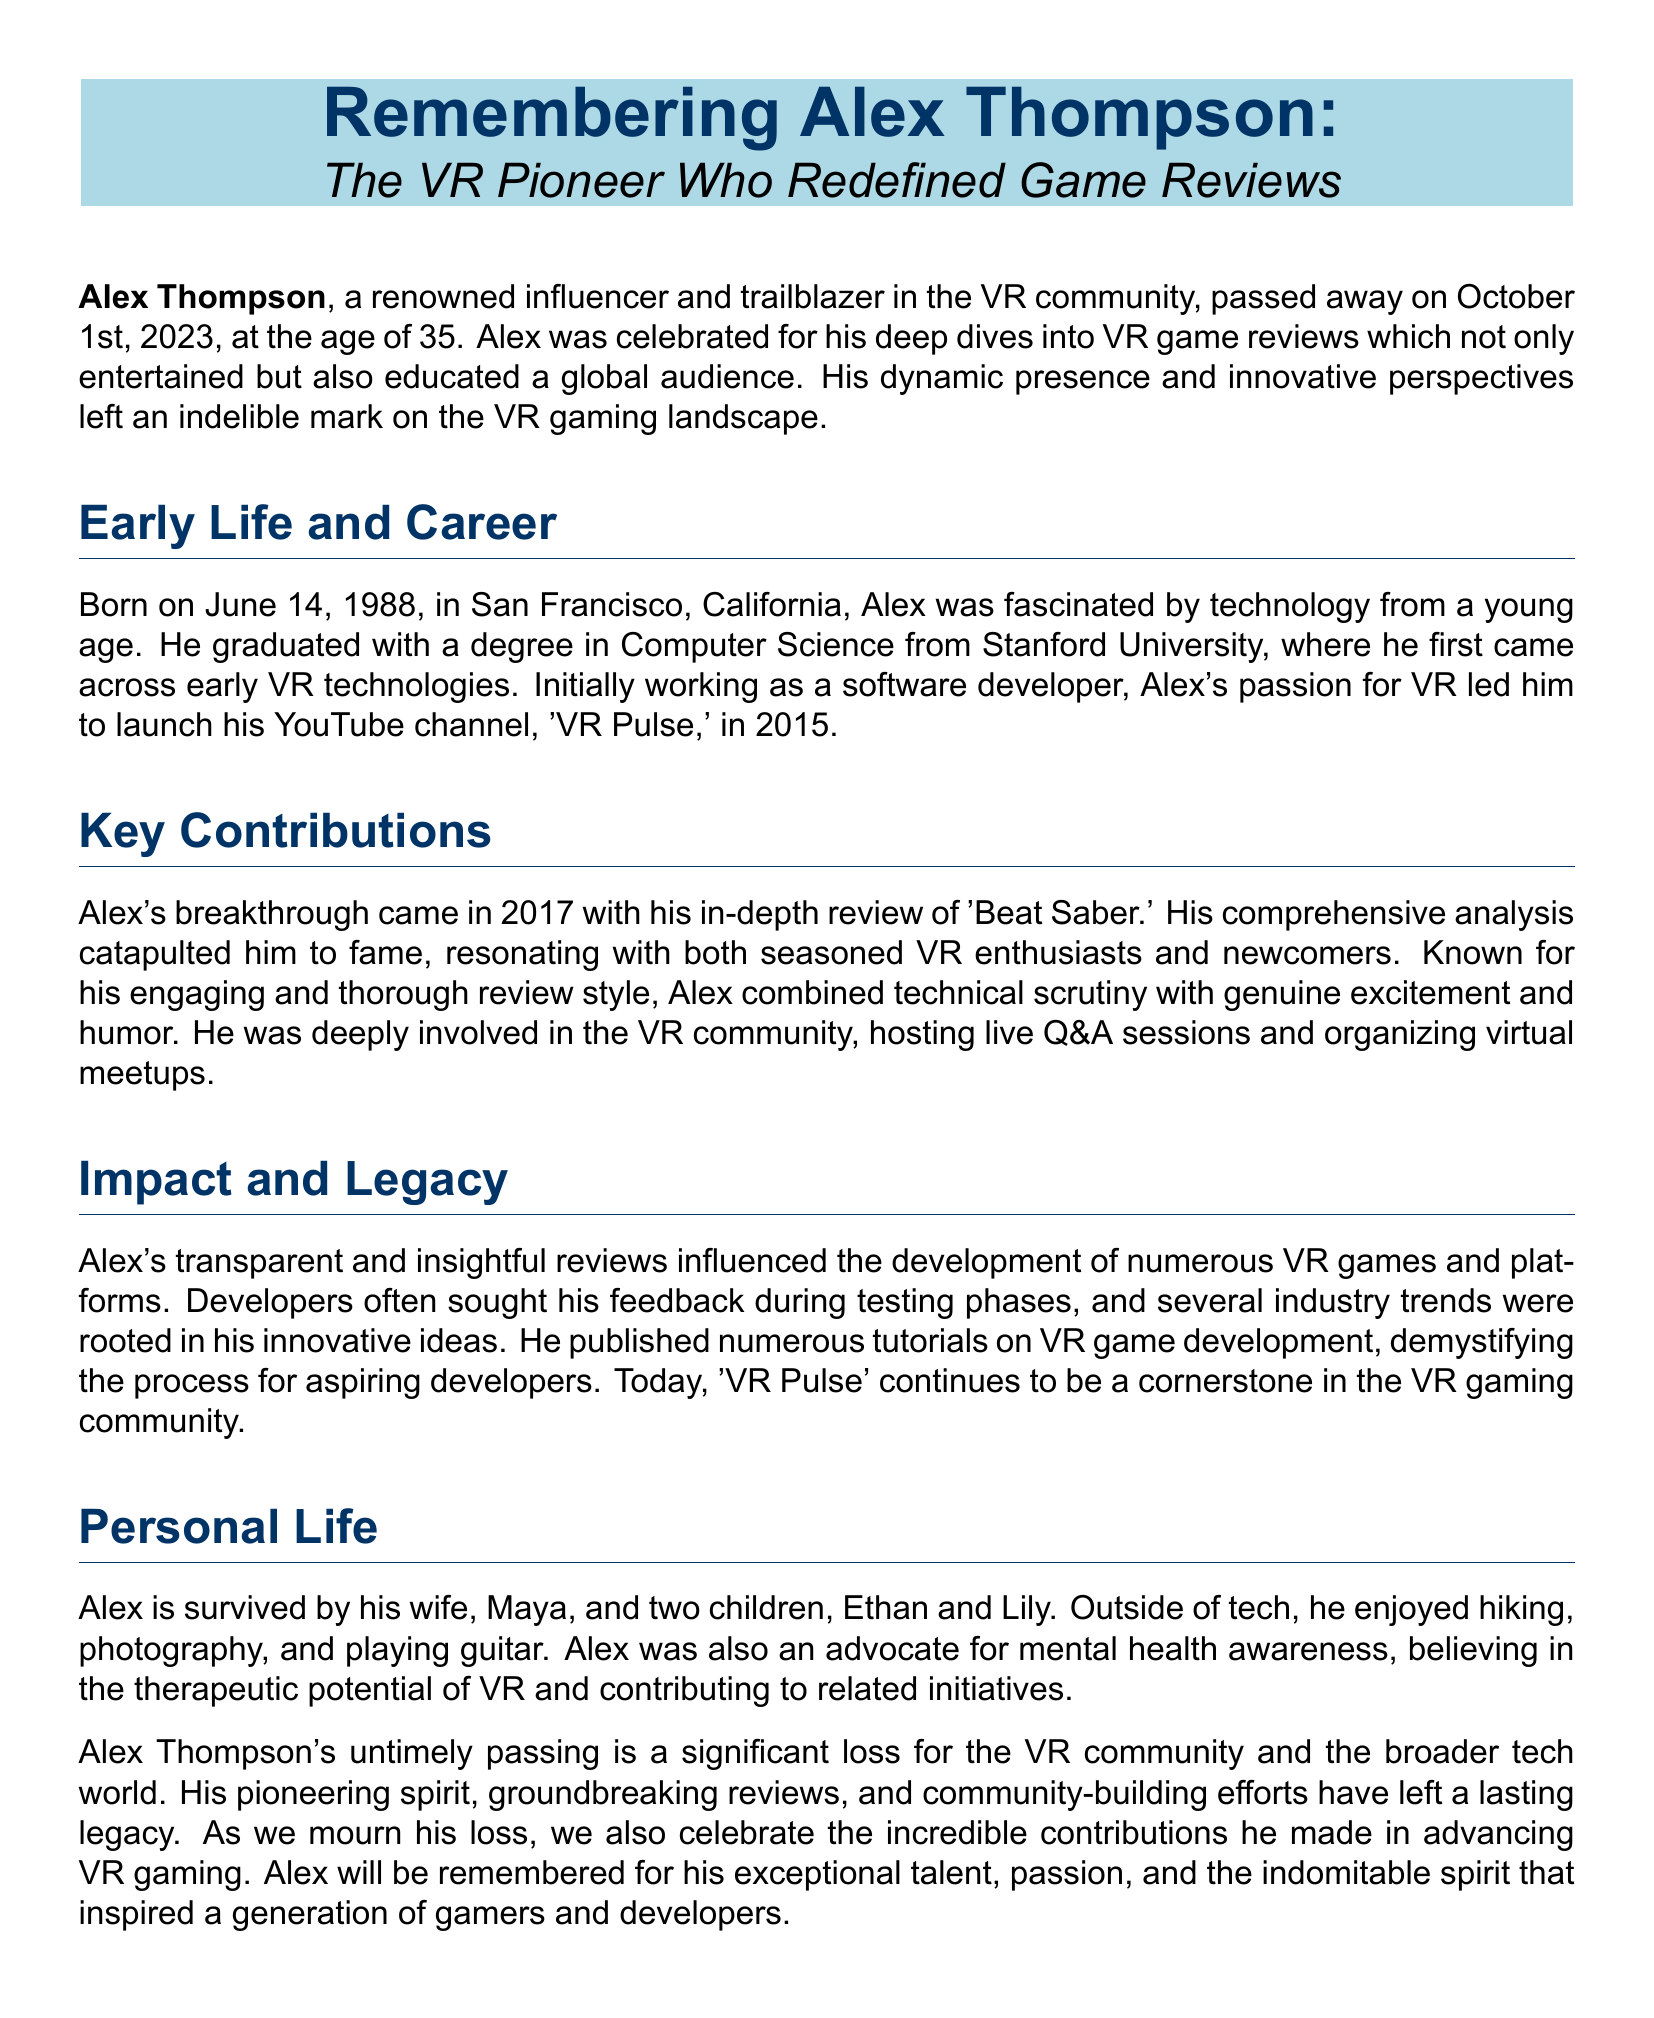what was Alex Thompson's birth date? Alex was born on June 14, 1988, as stated in the document.
Answer: June 14, 1988 what was the name of Alex Thompson's YouTube channel? The document mentions that his channel was named 'VR Pulse.'
Answer: VR Pulse what year did Alex Thompson launch his YouTube channel? The document states that he launched his channel in 2015.
Answer: 2015 what was Alex's notable review in 2017? The document highlights his in-depth review of 'Beat Saber' as a breakthrough achievement.
Answer: Beat Saber how many children did Alex Thompson have? The document indicates he is survived by two children, so we count them.
Answer: two what was one of Alex's hobbies outside of tech? The document lists hiking, photography, and playing guitar as his hobbies.
Answer: hiking what impact did Alex's reviews have on VR game developers? The document explains that developers often sought his feedback during testing phases.
Answer: feedback what advocacy was Alex involved in besides tech? The document mentions that he was an advocate for mental health awareness.
Answer: mental health awareness what legacy did Alex leave in the VR community? The document states that 'VR Pulse' continues to be a cornerstone in the VR gaming community.
Answer: cornerstone in VR gaming community 